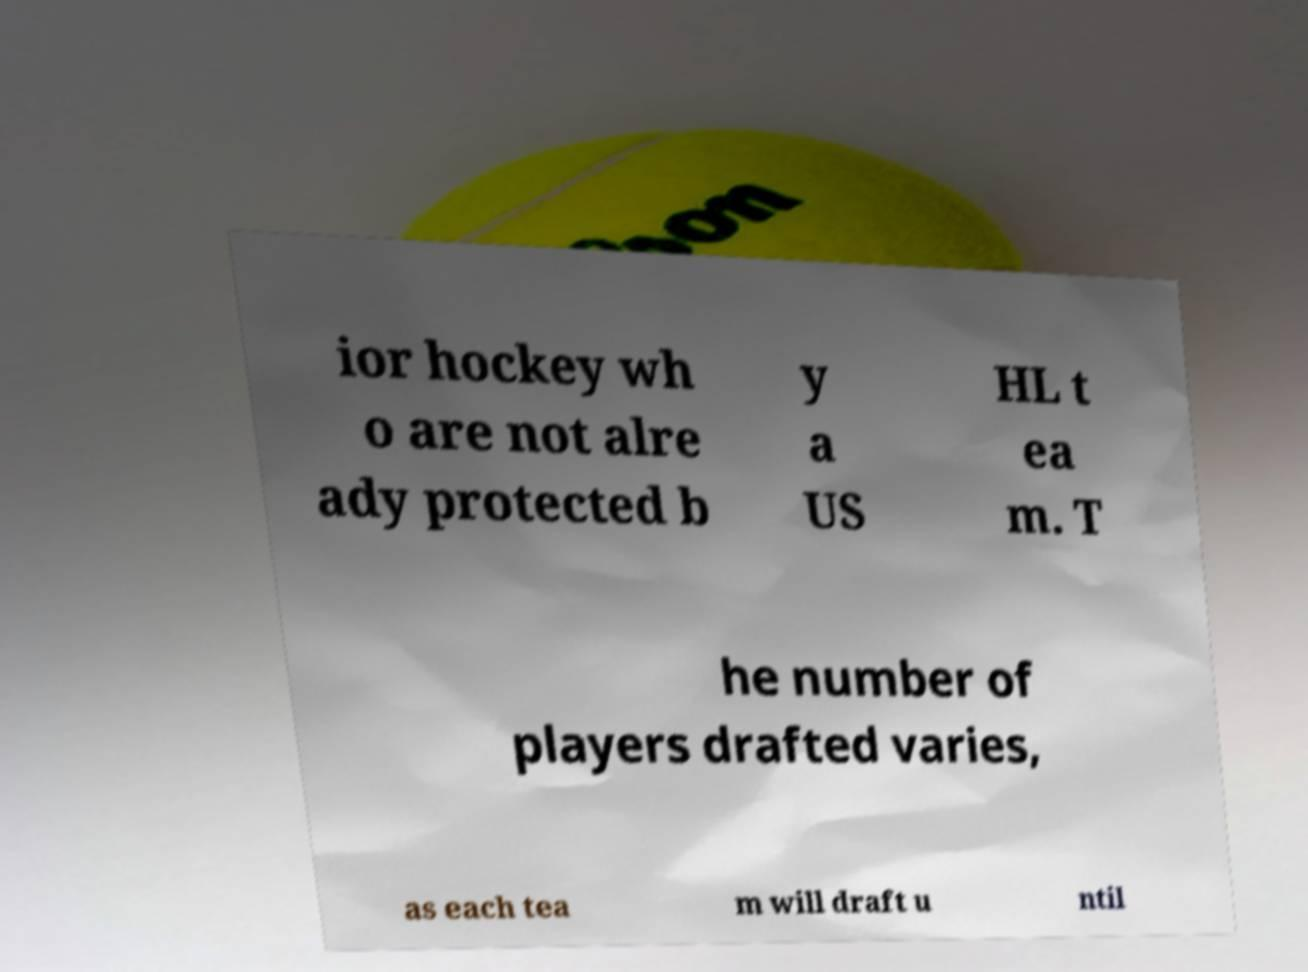Could you assist in decoding the text presented in this image and type it out clearly? ior hockey wh o are not alre ady protected b y a US HL t ea m. T he number of players drafted varies, as each tea m will draft u ntil 